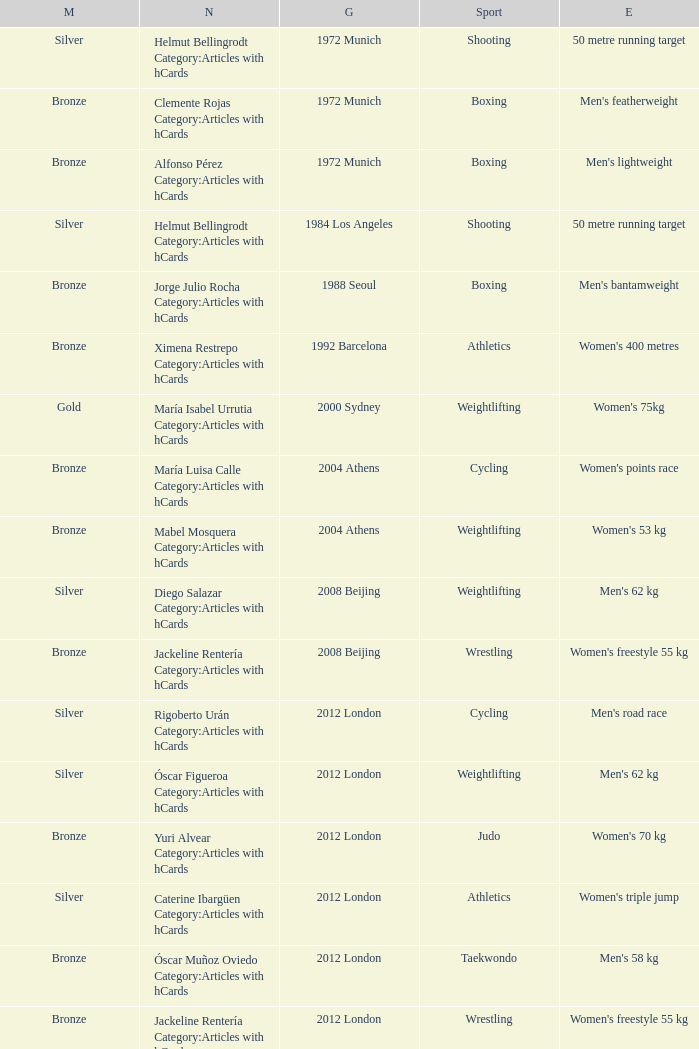What wrestling event was participated in during the 2008 Beijing games? Women's freestyle 55 kg. 